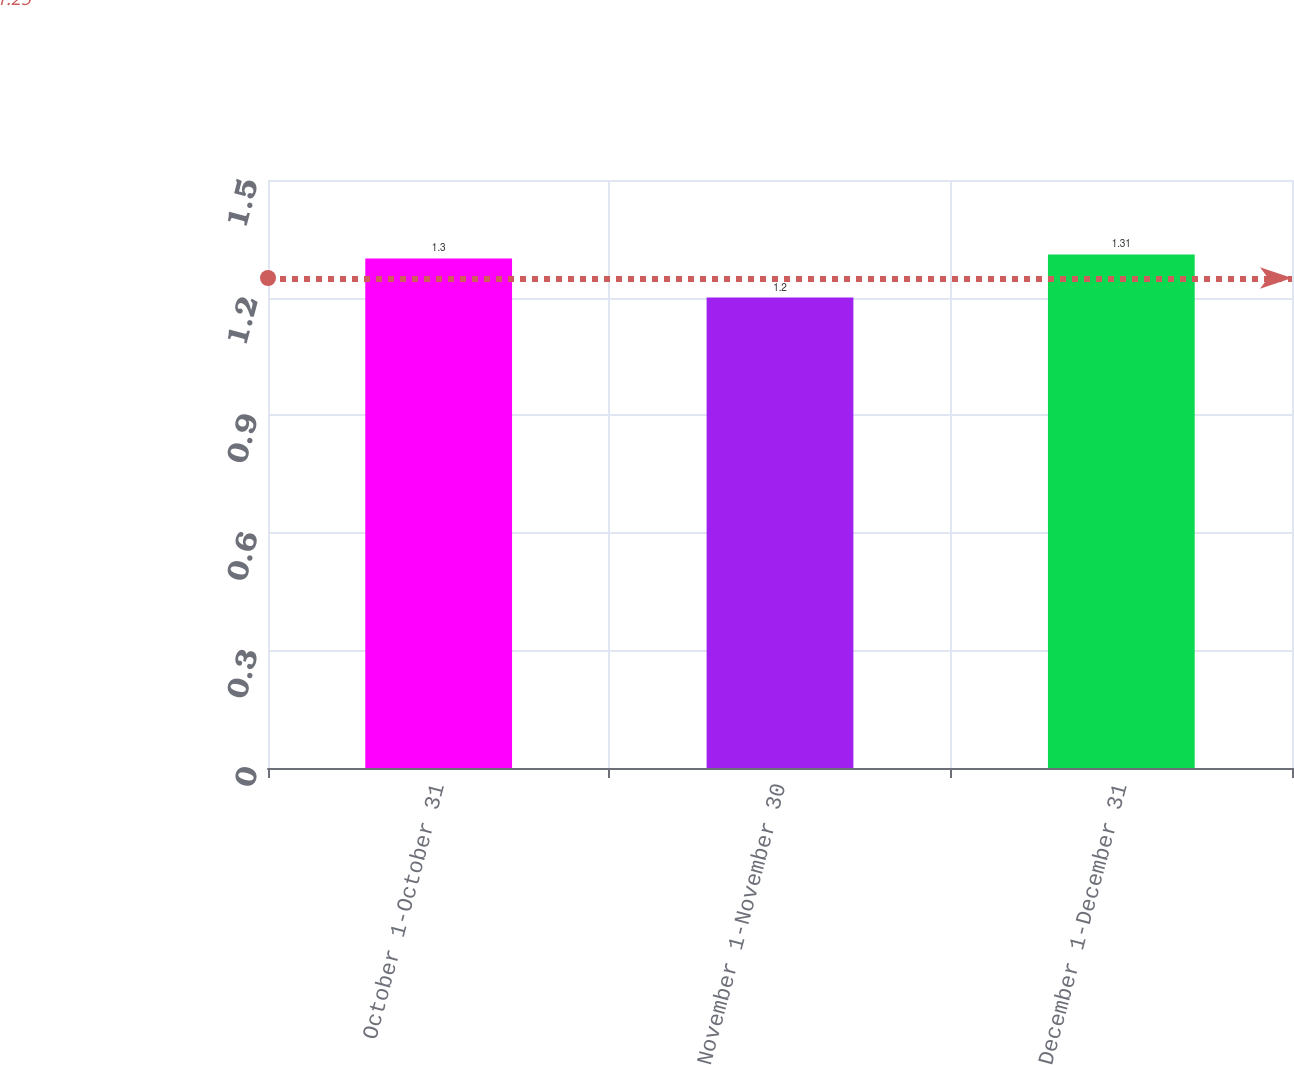<chart> <loc_0><loc_0><loc_500><loc_500><bar_chart><fcel>October 1-October 31<fcel>November 1-November 30<fcel>December 1-December 31<nl><fcel>1.3<fcel>1.2<fcel>1.31<nl></chart> 